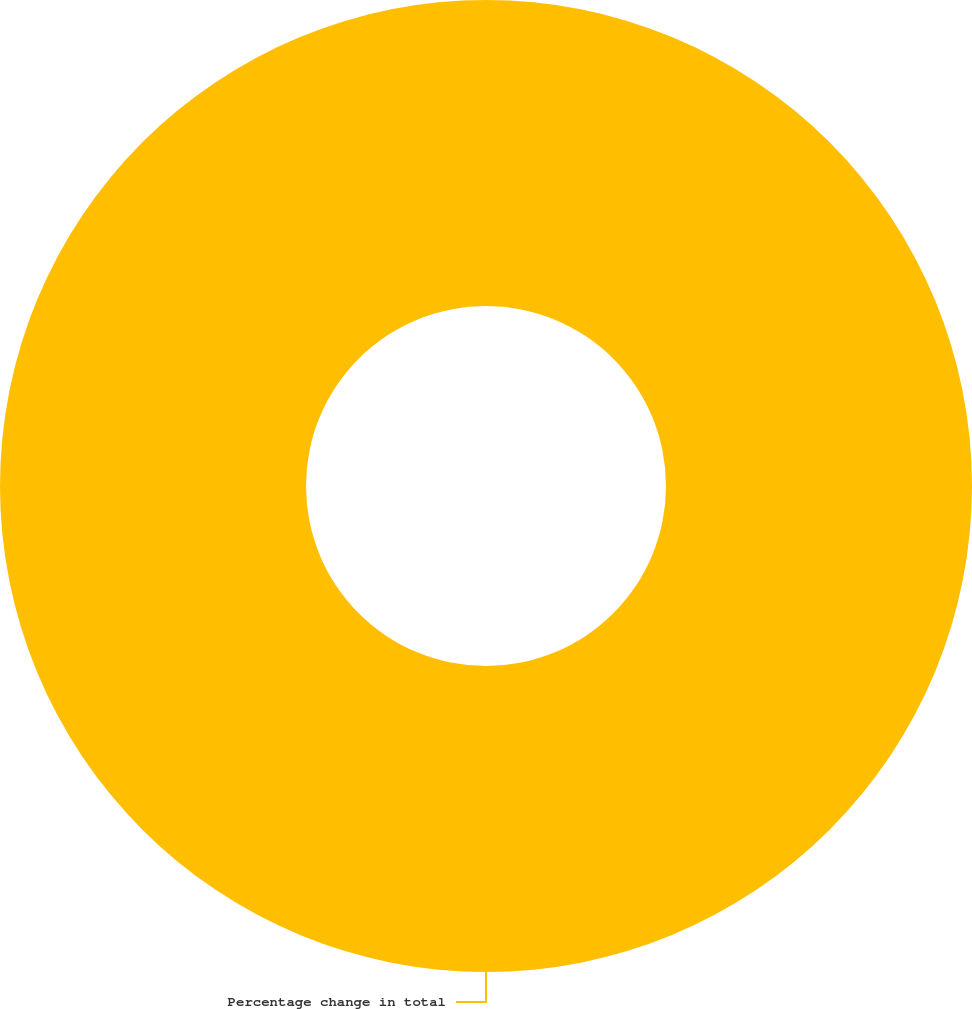Convert chart to OTSL. <chart><loc_0><loc_0><loc_500><loc_500><pie_chart><fcel>Percentage change in total<nl><fcel>100.0%<nl></chart> 